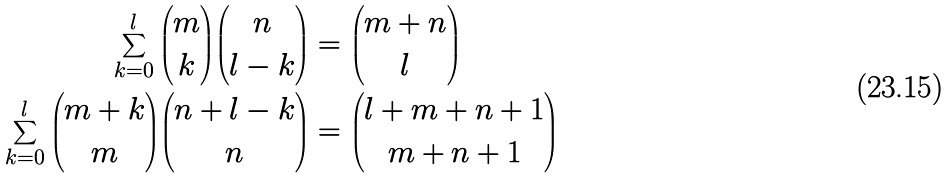<formula> <loc_0><loc_0><loc_500><loc_500>\sum _ { k = 0 } ^ { l } \binom { m } { k } \binom { n } { l - k } & = \binom { m + n } { l } \\ \sum _ { k = 0 } ^ { l } \binom { m + k } { m } \binom { n + l - k } { n } & = \binom { l + m + n + 1 } { m + n + 1 }</formula> 